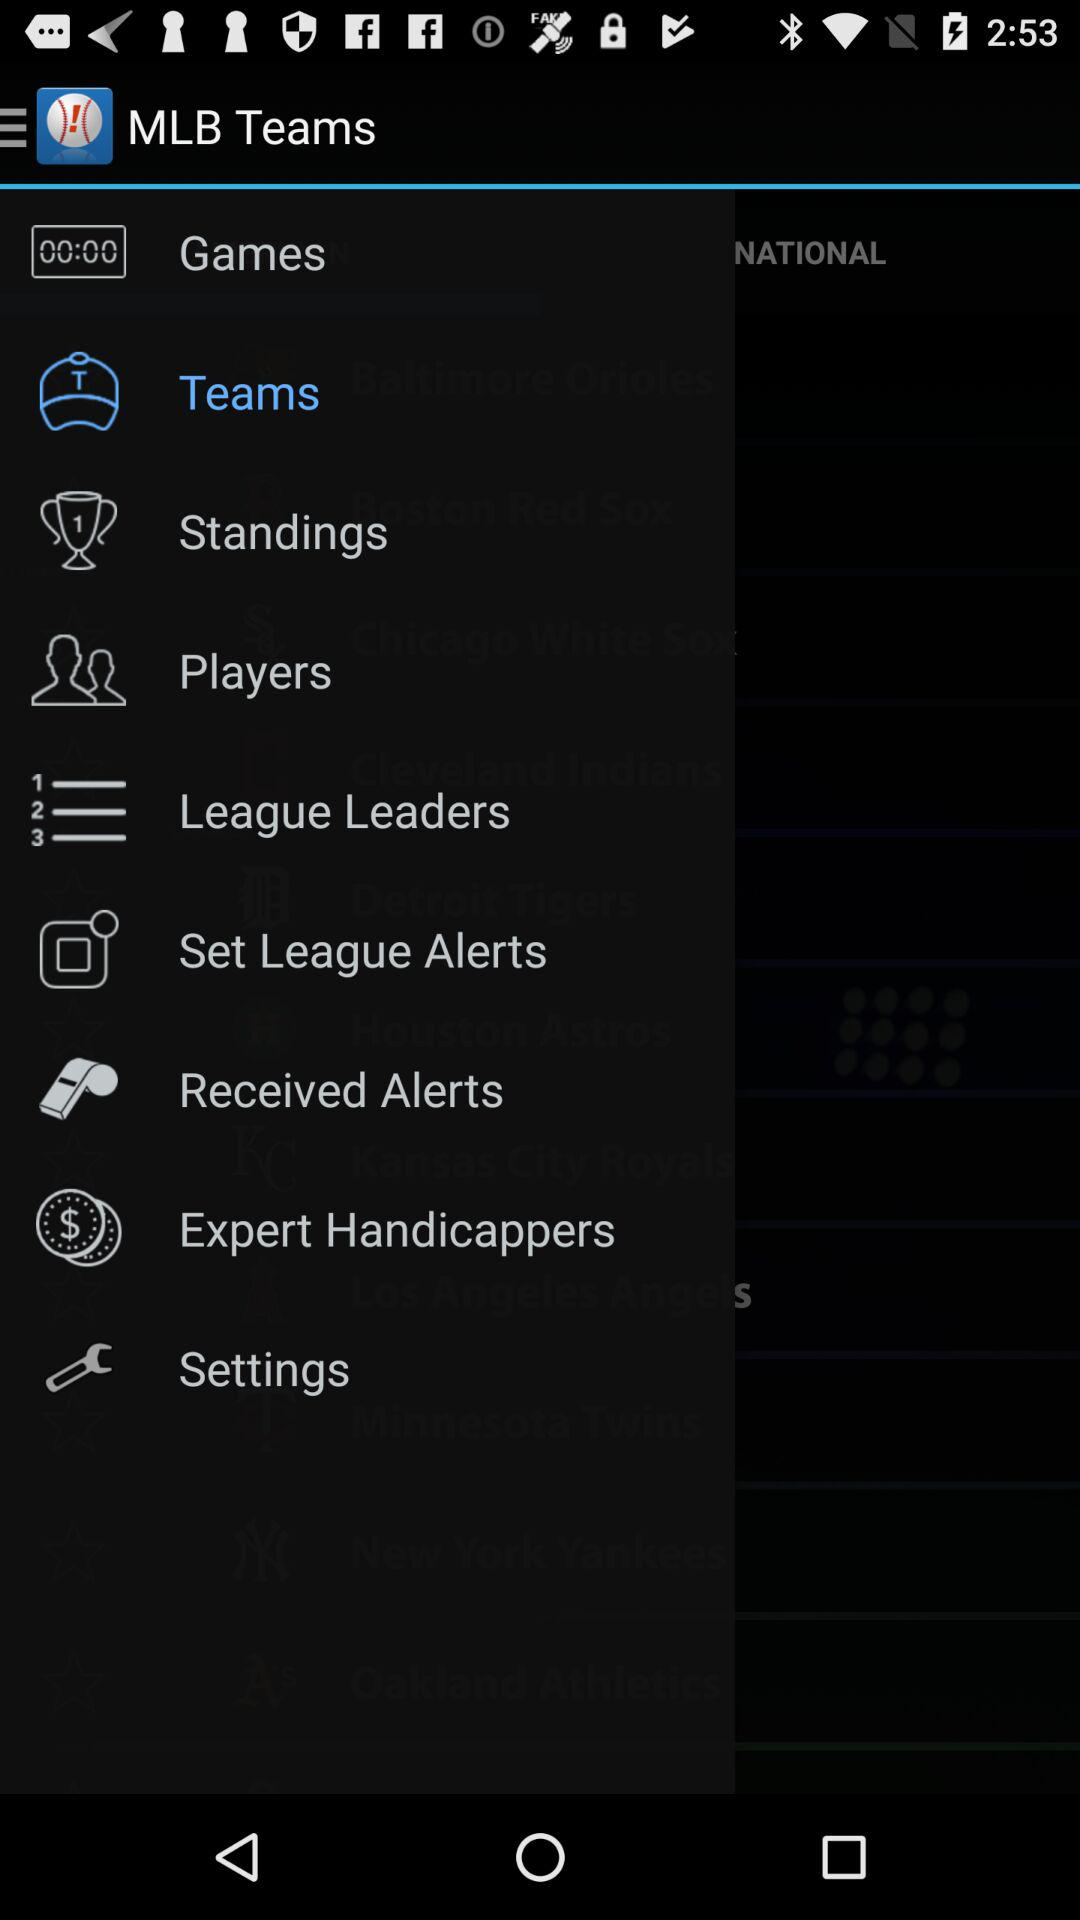What is the game type? The name type is National. 